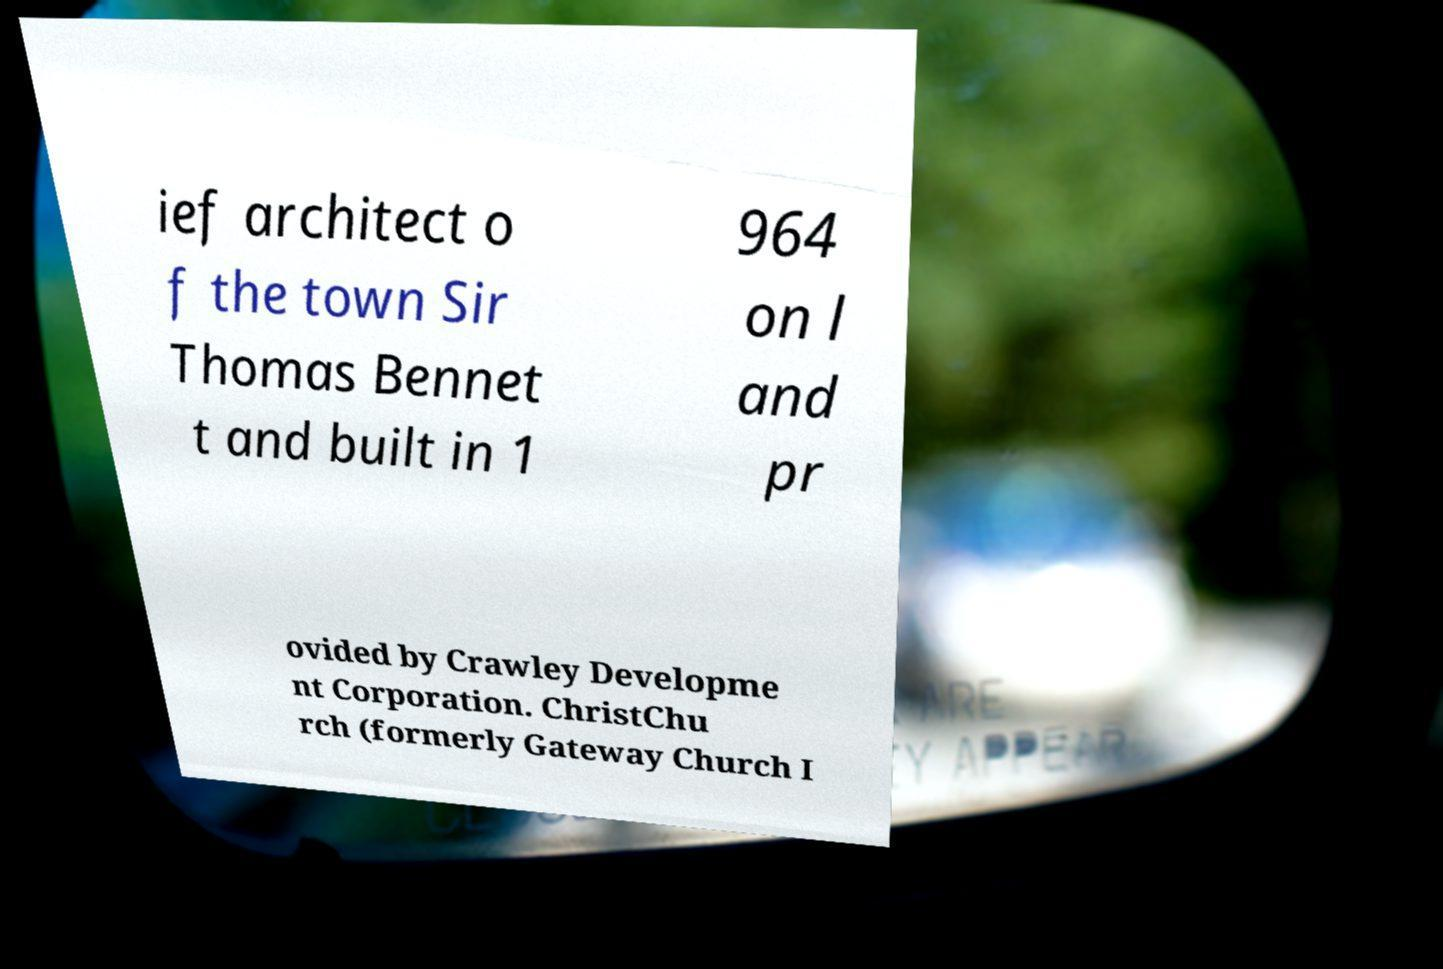I need the written content from this picture converted into text. Can you do that? ief architect o f the town Sir Thomas Bennet t and built in 1 964 on l and pr ovided by Crawley Developme nt Corporation. ChristChu rch (formerly Gateway Church I 